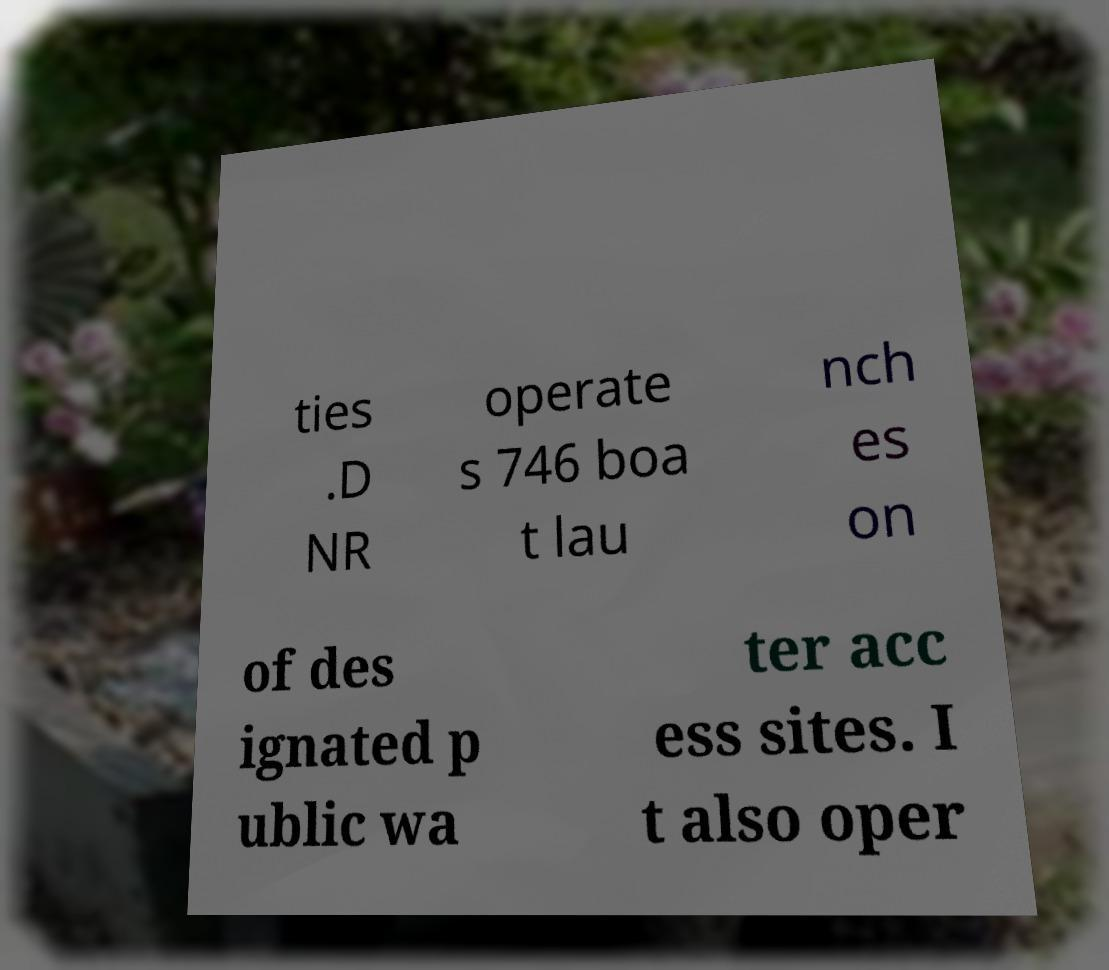Could you extract and type out the text from this image? ties .D NR operate s 746 boa t lau nch es on of des ignated p ublic wa ter acc ess sites. I t also oper 